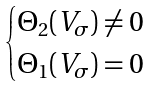<formula> <loc_0><loc_0><loc_500><loc_500>\begin{cases} \Theta _ { 2 } ( V _ { \sigma } ) \neq 0 \\ \Theta _ { 1 } ( V _ { \sigma } ) = 0 \end{cases}</formula> 